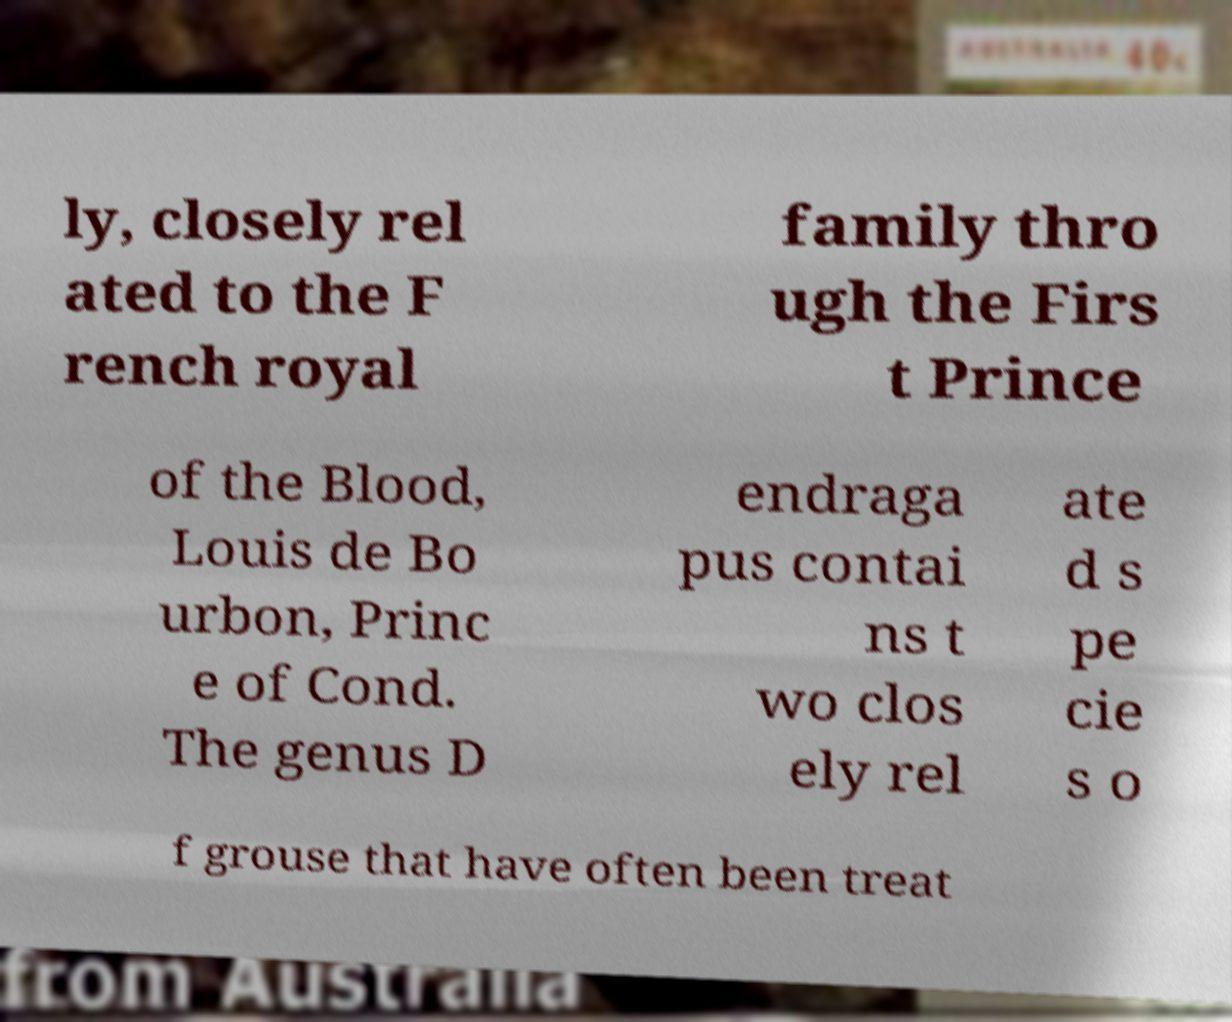Please identify and transcribe the text found in this image. ly, closely rel ated to the F rench royal family thro ugh the Firs t Prince of the Blood, Louis de Bo urbon, Princ e of Cond. The genus D endraga pus contai ns t wo clos ely rel ate d s pe cie s o f grouse that have often been treat 